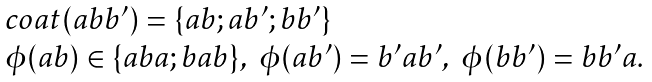<formula> <loc_0><loc_0><loc_500><loc_500>\begin{array} { l } c o a t ( a b b ^ { \prime } ) = \{ a b ; a b ^ { \prime } ; b b ^ { \prime } \} \\ \phi ( a b ) \in \{ a b a ; b a b \} , \ \phi ( a b ^ { \prime } ) = b ^ { \prime } a b ^ { \prime } , \ \phi ( b b ^ { \prime } ) = b b ^ { \prime } a . \end{array}</formula> 